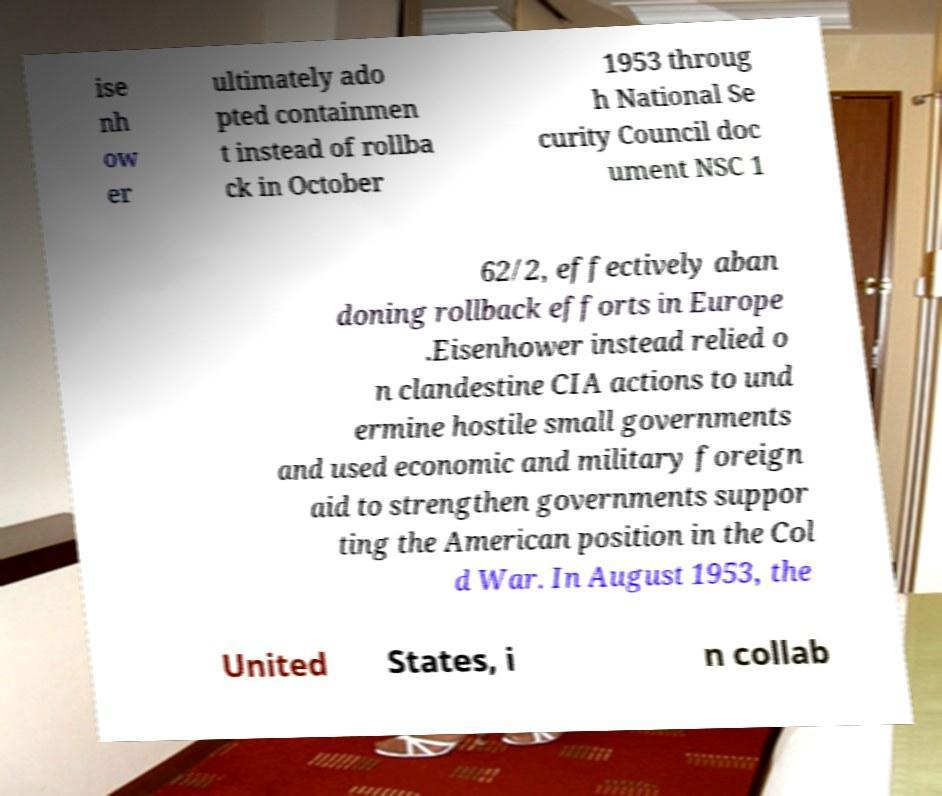Could you extract and type out the text from this image? ise nh ow er ultimately ado pted containmen t instead of rollba ck in October 1953 throug h National Se curity Council doc ument NSC 1 62/2, effectively aban doning rollback efforts in Europe .Eisenhower instead relied o n clandestine CIA actions to und ermine hostile small governments and used economic and military foreign aid to strengthen governments suppor ting the American position in the Col d War. In August 1953, the United States, i n collab 